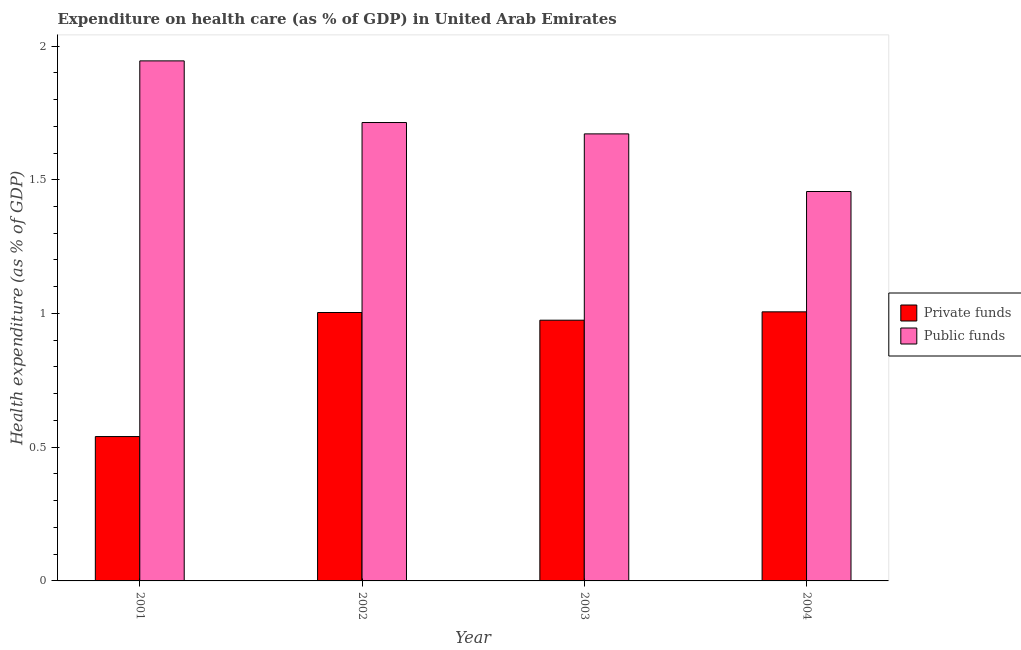Are the number of bars per tick equal to the number of legend labels?
Your answer should be very brief. Yes. How many bars are there on the 1st tick from the right?
Offer a very short reply. 2. In how many cases, is the number of bars for a given year not equal to the number of legend labels?
Your answer should be compact. 0. What is the amount of public funds spent in healthcare in 2001?
Ensure brevity in your answer.  1.94. Across all years, what is the maximum amount of public funds spent in healthcare?
Provide a short and direct response. 1.94. Across all years, what is the minimum amount of public funds spent in healthcare?
Provide a succinct answer. 1.46. In which year was the amount of public funds spent in healthcare maximum?
Your response must be concise. 2001. In which year was the amount of private funds spent in healthcare minimum?
Provide a succinct answer. 2001. What is the total amount of public funds spent in healthcare in the graph?
Make the answer very short. 6.79. What is the difference between the amount of private funds spent in healthcare in 2001 and that in 2003?
Ensure brevity in your answer.  -0.44. What is the difference between the amount of private funds spent in healthcare in 2001 and the amount of public funds spent in healthcare in 2002?
Provide a succinct answer. -0.46. What is the average amount of public funds spent in healthcare per year?
Offer a very short reply. 1.7. In the year 2003, what is the difference between the amount of private funds spent in healthcare and amount of public funds spent in healthcare?
Provide a short and direct response. 0. What is the ratio of the amount of public funds spent in healthcare in 2001 to that in 2002?
Offer a terse response. 1.13. Is the amount of public funds spent in healthcare in 2002 less than that in 2003?
Ensure brevity in your answer.  No. What is the difference between the highest and the second highest amount of public funds spent in healthcare?
Offer a very short reply. 0.23. What is the difference between the highest and the lowest amount of private funds spent in healthcare?
Give a very brief answer. 0.47. In how many years, is the amount of public funds spent in healthcare greater than the average amount of public funds spent in healthcare taken over all years?
Offer a very short reply. 2. What does the 2nd bar from the left in 2003 represents?
Offer a terse response. Public funds. What does the 2nd bar from the right in 2001 represents?
Your answer should be very brief. Private funds. Are all the bars in the graph horizontal?
Offer a terse response. No. How many years are there in the graph?
Give a very brief answer. 4. What is the difference between two consecutive major ticks on the Y-axis?
Provide a succinct answer. 0.5. Are the values on the major ticks of Y-axis written in scientific E-notation?
Offer a very short reply. No. Does the graph contain grids?
Your response must be concise. No. Where does the legend appear in the graph?
Provide a short and direct response. Center right. How are the legend labels stacked?
Ensure brevity in your answer.  Vertical. What is the title of the graph?
Offer a very short reply. Expenditure on health care (as % of GDP) in United Arab Emirates. What is the label or title of the X-axis?
Make the answer very short. Year. What is the label or title of the Y-axis?
Ensure brevity in your answer.  Health expenditure (as % of GDP). What is the Health expenditure (as % of GDP) in Private funds in 2001?
Give a very brief answer. 0.54. What is the Health expenditure (as % of GDP) in Public funds in 2001?
Offer a very short reply. 1.94. What is the Health expenditure (as % of GDP) in Private funds in 2002?
Your response must be concise. 1. What is the Health expenditure (as % of GDP) of Public funds in 2002?
Make the answer very short. 1.71. What is the Health expenditure (as % of GDP) in Private funds in 2003?
Make the answer very short. 0.97. What is the Health expenditure (as % of GDP) of Public funds in 2003?
Your response must be concise. 1.67. What is the Health expenditure (as % of GDP) of Private funds in 2004?
Your answer should be compact. 1.01. What is the Health expenditure (as % of GDP) of Public funds in 2004?
Make the answer very short. 1.46. Across all years, what is the maximum Health expenditure (as % of GDP) in Private funds?
Offer a terse response. 1.01. Across all years, what is the maximum Health expenditure (as % of GDP) in Public funds?
Provide a short and direct response. 1.94. Across all years, what is the minimum Health expenditure (as % of GDP) of Private funds?
Give a very brief answer. 0.54. Across all years, what is the minimum Health expenditure (as % of GDP) of Public funds?
Your answer should be very brief. 1.46. What is the total Health expenditure (as % of GDP) in Private funds in the graph?
Your response must be concise. 3.52. What is the total Health expenditure (as % of GDP) in Public funds in the graph?
Your answer should be compact. 6.79. What is the difference between the Health expenditure (as % of GDP) of Private funds in 2001 and that in 2002?
Your response must be concise. -0.46. What is the difference between the Health expenditure (as % of GDP) in Public funds in 2001 and that in 2002?
Your response must be concise. 0.23. What is the difference between the Health expenditure (as % of GDP) in Private funds in 2001 and that in 2003?
Offer a very short reply. -0.44. What is the difference between the Health expenditure (as % of GDP) in Public funds in 2001 and that in 2003?
Make the answer very short. 0.27. What is the difference between the Health expenditure (as % of GDP) of Private funds in 2001 and that in 2004?
Ensure brevity in your answer.  -0.47. What is the difference between the Health expenditure (as % of GDP) in Public funds in 2001 and that in 2004?
Your answer should be very brief. 0.49. What is the difference between the Health expenditure (as % of GDP) in Private funds in 2002 and that in 2003?
Your response must be concise. 0.03. What is the difference between the Health expenditure (as % of GDP) of Public funds in 2002 and that in 2003?
Ensure brevity in your answer.  0.04. What is the difference between the Health expenditure (as % of GDP) of Private funds in 2002 and that in 2004?
Give a very brief answer. -0. What is the difference between the Health expenditure (as % of GDP) in Public funds in 2002 and that in 2004?
Your response must be concise. 0.26. What is the difference between the Health expenditure (as % of GDP) of Private funds in 2003 and that in 2004?
Provide a short and direct response. -0.03. What is the difference between the Health expenditure (as % of GDP) in Public funds in 2003 and that in 2004?
Your response must be concise. 0.22. What is the difference between the Health expenditure (as % of GDP) in Private funds in 2001 and the Health expenditure (as % of GDP) in Public funds in 2002?
Provide a succinct answer. -1.17. What is the difference between the Health expenditure (as % of GDP) in Private funds in 2001 and the Health expenditure (as % of GDP) in Public funds in 2003?
Offer a terse response. -1.13. What is the difference between the Health expenditure (as % of GDP) in Private funds in 2001 and the Health expenditure (as % of GDP) in Public funds in 2004?
Provide a succinct answer. -0.92. What is the difference between the Health expenditure (as % of GDP) of Private funds in 2002 and the Health expenditure (as % of GDP) of Public funds in 2003?
Your answer should be compact. -0.67. What is the difference between the Health expenditure (as % of GDP) of Private funds in 2002 and the Health expenditure (as % of GDP) of Public funds in 2004?
Provide a short and direct response. -0.45. What is the difference between the Health expenditure (as % of GDP) in Private funds in 2003 and the Health expenditure (as % of GDP) in Public funds in 2004?
Offer a terse response. -0.48. What is the average Health expenditure (as % of GDP) of Private funds per year?
Ensure brevity in your answer.  0.88. What is the average Health expenditure (as % of GDP) of Public funds per year?
Provide a succinct answer. 1.7. In the year 2001, what is the difference between the Health expenditure (as % of GDP) in Private funds and Health expenditure (as % of GDP) in Public funds?
Keep it short and to the point. -1.4. In the year 2002, what is the difference between the Health expenditure (as % of GDP) in Private funds and Health expenditure (as % of GDP) in Public funds?
Provide a short and direct response. -0.71. In the year 2003, what is the difference between the Health expenditure (as % of GDP) of Private funds and Health expenditure (as % of GDP) of Public funds?
Offer a terse response. -0.7. In the year 2004, what is the difference between the Health expenditure (as % of GDP) of Private funds and Health expenditure (as % of GDP) of Public funds?
Keep it short and to the point. -0.45. What is the ratio of the Health expenditure (as % of GDP) of Private funds in 2001 to that in 2002?
Give a very brief answer. 0.54. What is the ratio of the Health expenditure (as % of GDP) of Public funds in 2001 to that in 2002?
Your answer should be compact. 1.13. What is the ratio of the Health expenditure (as % of GDP) in Private funds in 2001 to that in 2003?
Ensure brevity in your answer.  0.55. What is the ratio of the Health expenditure (as % of GDP) of Public funds in 2001 to that in 2003?
Offer a very short reply. 1.16. What is the ratio of the Health expenditure (as % of GDP) of Private funds in 2001 to that in 2004?
Ensure brevity in your answer.  0.54. What is the ratio of the Health expenditure (as % of GDP) of Public funds in 2001 to that in 2004?
Give a very brief answer. 1.34. What is the ratio of the Health expenditure (as % of GDP) in Private funds in 2002 to that in 2003?
Give a very brief answer. 1.03. What is the ratio of the Health expenditure (as % of GDP) of Public funds in 2002 to that in 2003?
Your answer should be compact. 1.03. What is the ratio of the Health expenditure (as % of GDP) in Public funds in 2002 to that in 2004?
Provide a short and direct response. 1.18. What is the ratio of the Health expenditure (as % of GDP) of Private funds in 2003 to that in 2004?
Provide a short and direct response. 0.97. What is the ratio of the Health expenditure (as % of GDP) in Public funds in 2003 to that in 2004?
Offer a terse response. 1.15. What is the difference between the highest and the second highest Health expenditure (as % of GDP) in Private funds?
Provide a succinct answer. 0. What is the difference between the highest and the second highest Health expenditure (as % of GDP) of Public funds?
Your response must be concise. 0.23. What is the difference between the highest and the lowest Health expenditure (as % of GDP) in Private funds?
Provide a short and direct response. 0.47. What is the difference between the highest and the lowest Health expenditure (as % of GDP) of Public funds?
Provide a short and direct response. 0.49. 